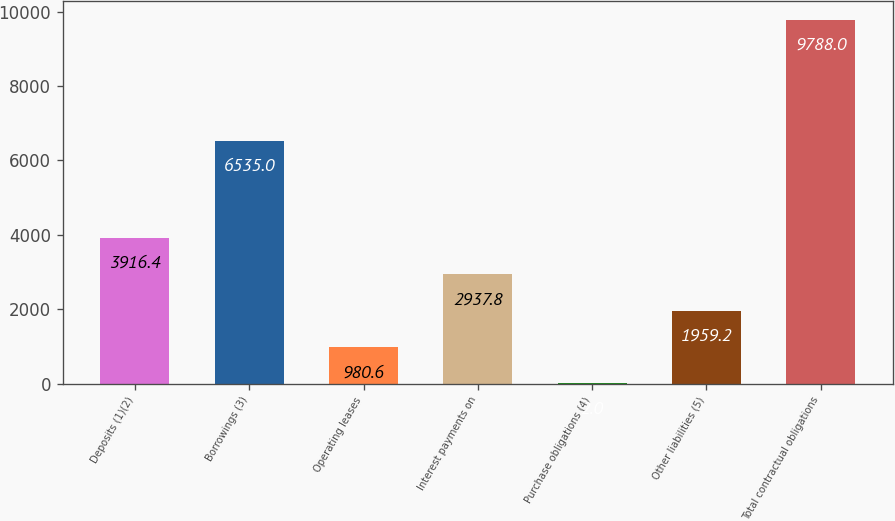Convert chart. <chart><loc_0><loc_0><loc_500><loc_500><bar_chart><fcel>Deposits (1)(2)<fcel>Borrowings (3)<fcel>Operating leases<fcel>Interest payments on<fcel>Purchase obligations (4)<fcel>Other liabilities (5)<fcel>Total contractual obligations<nl><fcel>3916.4<fcel>6535<fcel>980.6<fcel>2937.8<fcel>2<fcel>1959.2<fcel>9788<nl></chart> 